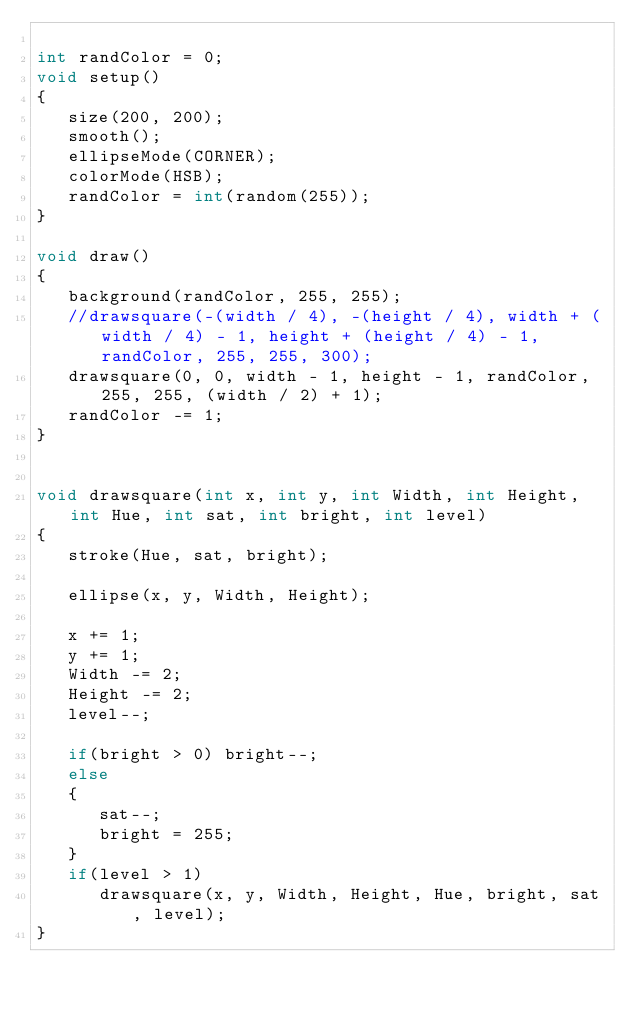Convert code to text. <code><loc_0><loc_0><loc_500><loc_500><_Java_>
int randColor = 0;
void setup()
{ 
   size(200, 200);
   smooth();
   ellipseMode(CORNER);
   colorMode(HSB);
   randColor = int(random(255));
}

void draw()
{
   background(randColor, 255, 255);
   //drawsquare(-(width / 4), -(height / 4), width + (width / 4) - 1, height + (height / 4) - 1, randColor, 255, 255, 300);
   drawsquare(0, 0, width - 1, height - 1, randColor, 255, 255, (width / 2) + 1);
   randColor -= 1;
}


void drawsquare(int x, int y, int Width, int Height, int Hue, int sat, int bright, int level)
{
   stroke(Hue, sat, bright);
   
   ellipse(x, y, Width, Height);

   x += 1;
   y += 1;
   Width -= 2;
   Height -= 2;
   level--;

   if(bright > 0) bright--;
   else
   {
      sat--;
      bright = 255;
   }
   if(level > 1)
      drawsquare(x, y, Width, Height, Hue, bright, sat, level);
}
</code> 